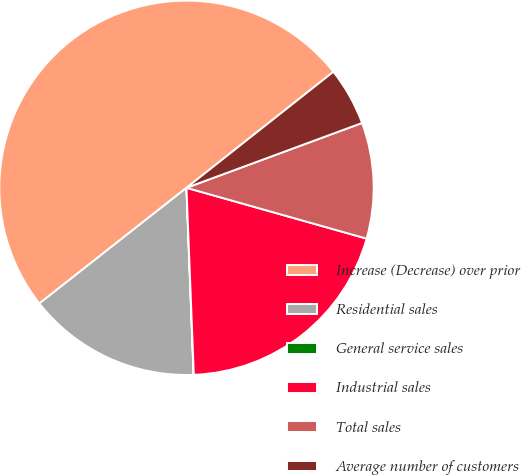Convert chart to OTSL. <chart><loc_0><loc_0><loc_500><loc_500><pie_chart><fcel>Increase (Decrease) over prior<fcel>Residential sales<fcel>General service sales<fcel>Industrial sales<fcel>Total sales<fcel>Average number of customers<nl><fcel>49.97%<fcel>15.0%<fcel>0.02%<fcel>20.0%<fcel>10.01%<fcel>5.01%<nl></chart> 